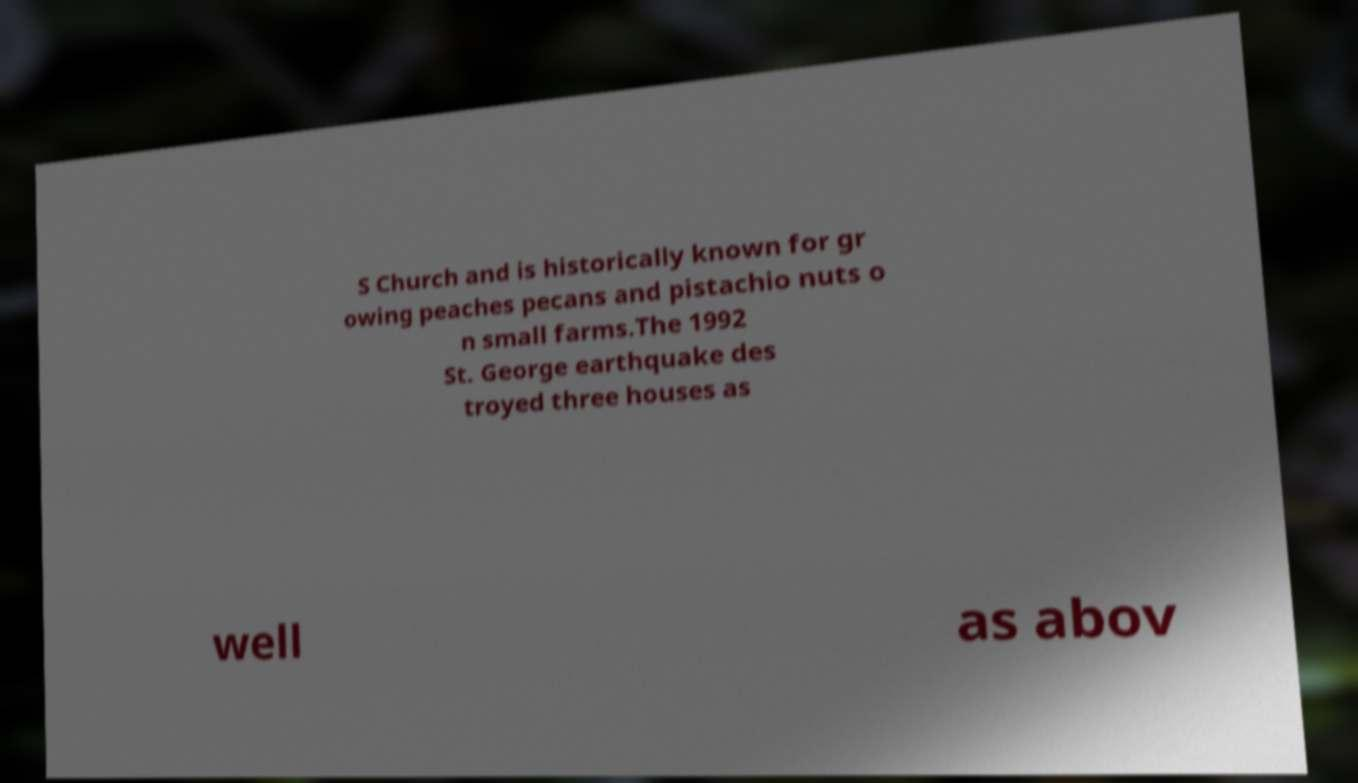There's text embedded in this image that I need extracted. Can you transcribe it verbatim? S Church and is historically known for gr owing peaches pecans and pistachio nuts o n small farms.The 1992 St. George earthquake des troyed three houses as well as abov 